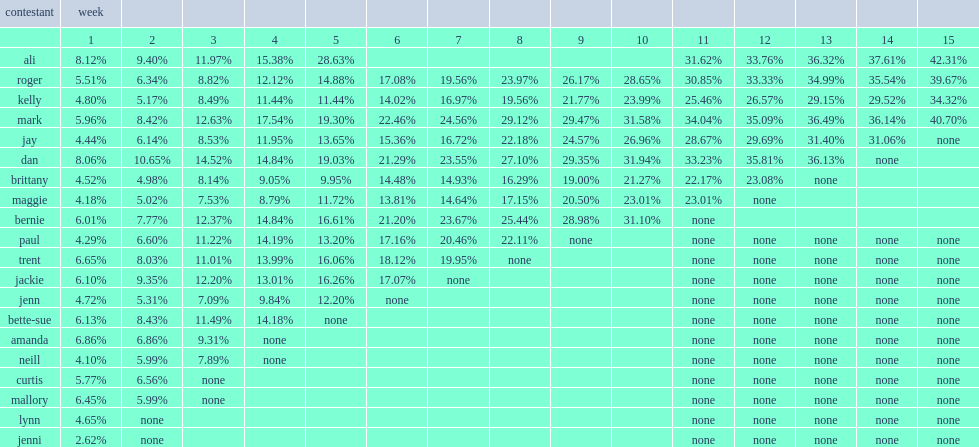What was contestant mark's weight lost in the 10th week? 31.58. 